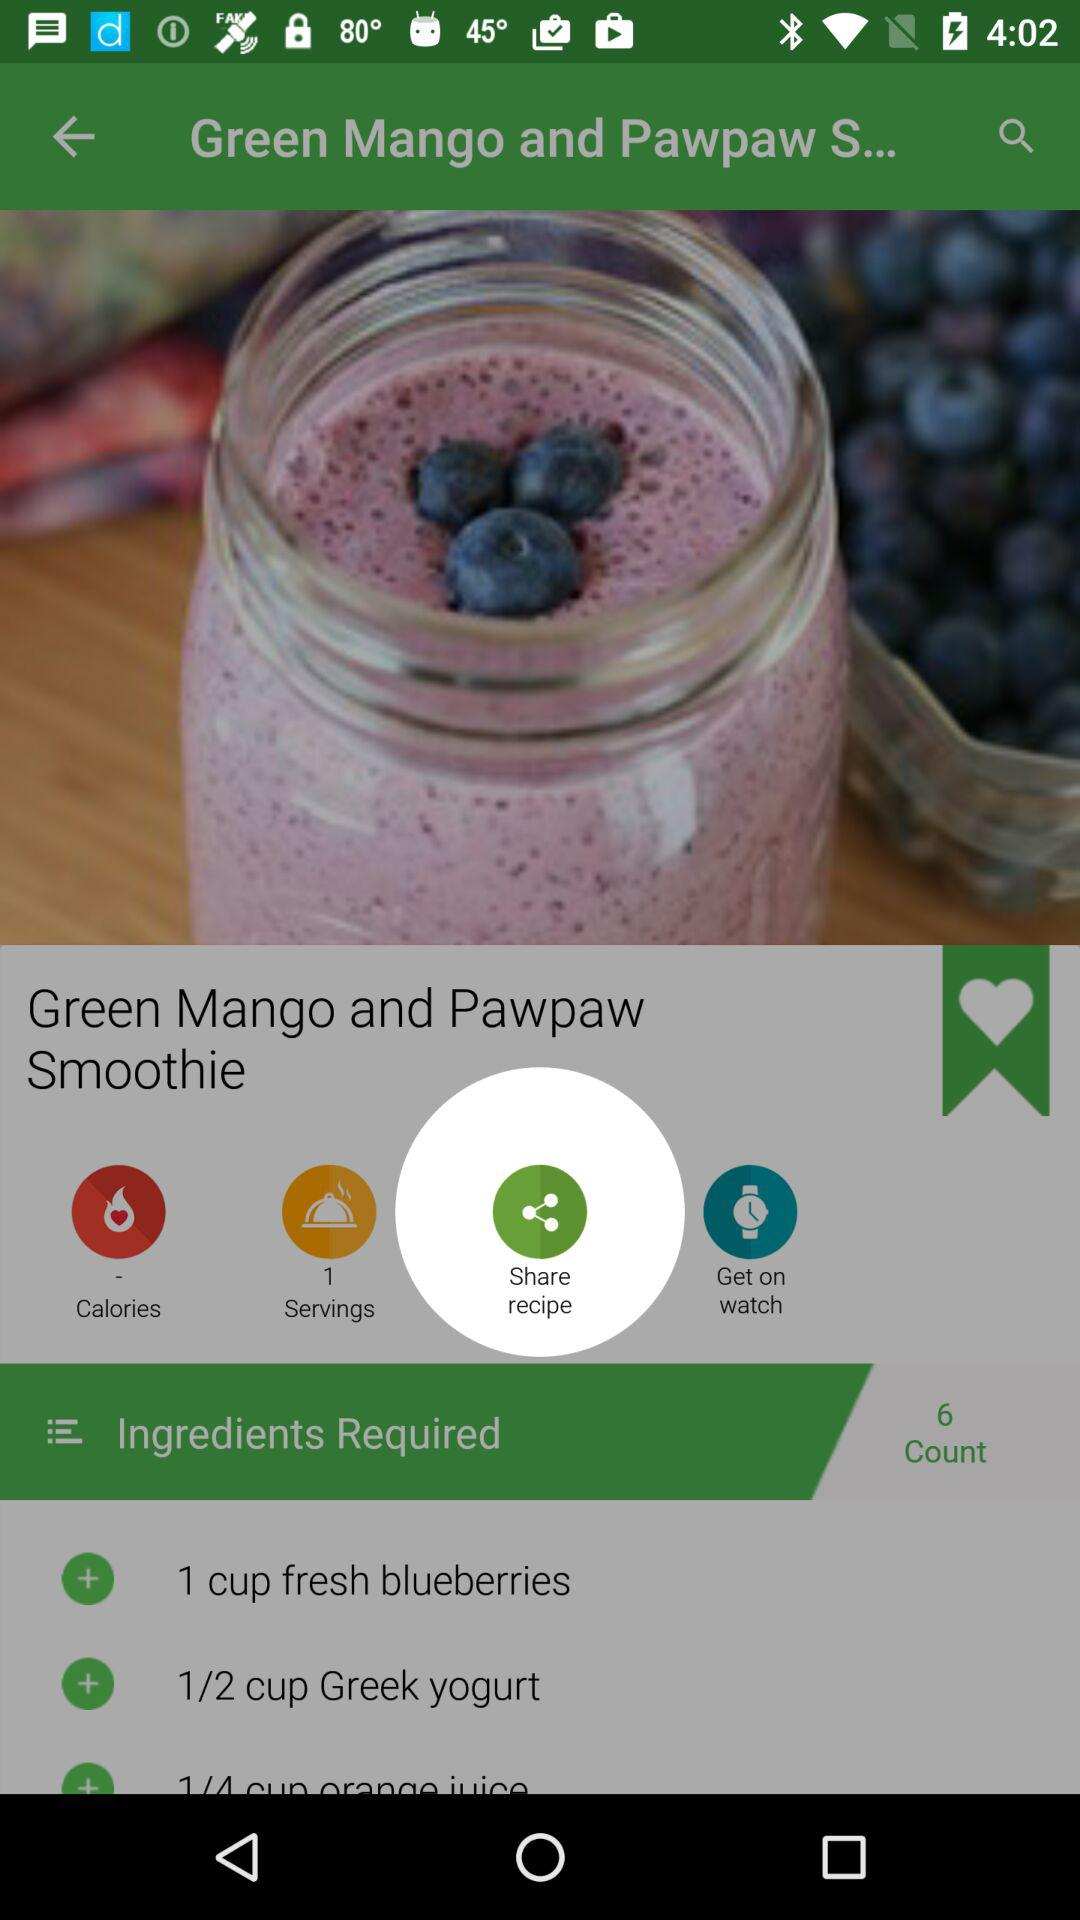How many servings are there? There is 1 serving. 